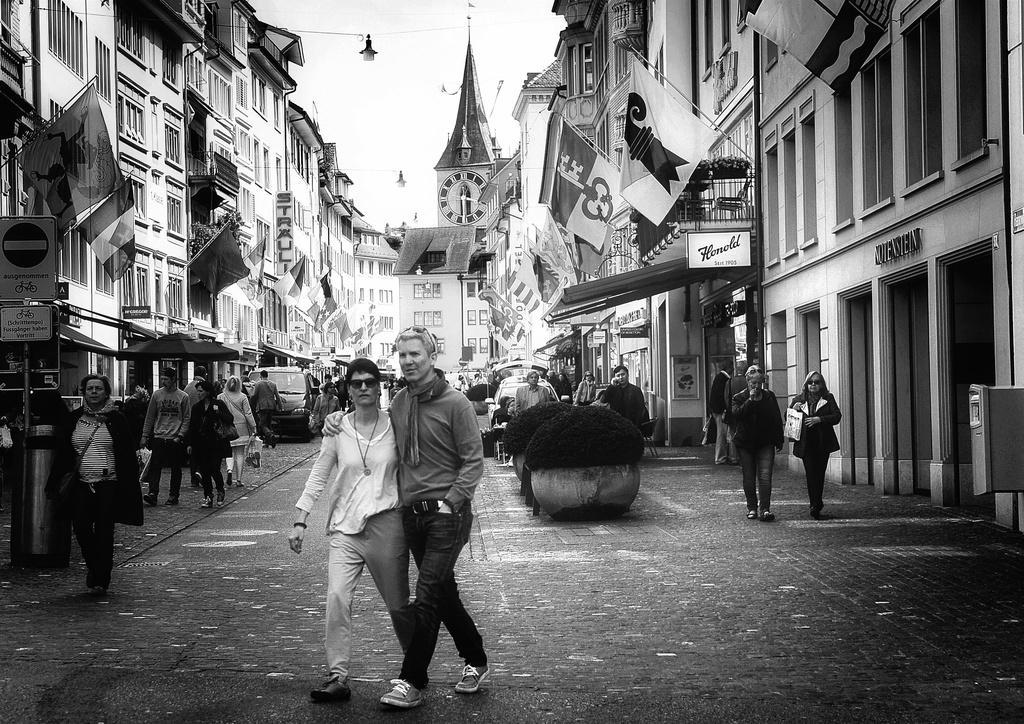Could you give a brief overview of what you see in this image? In the image we can see the black and white picture of the people walking, they are wearing clothes and some of them are wearing shoes and carrying bags. Here we can see the plant pots, road and vehicles on the road. We can even see the buildings, flags and the sky. 